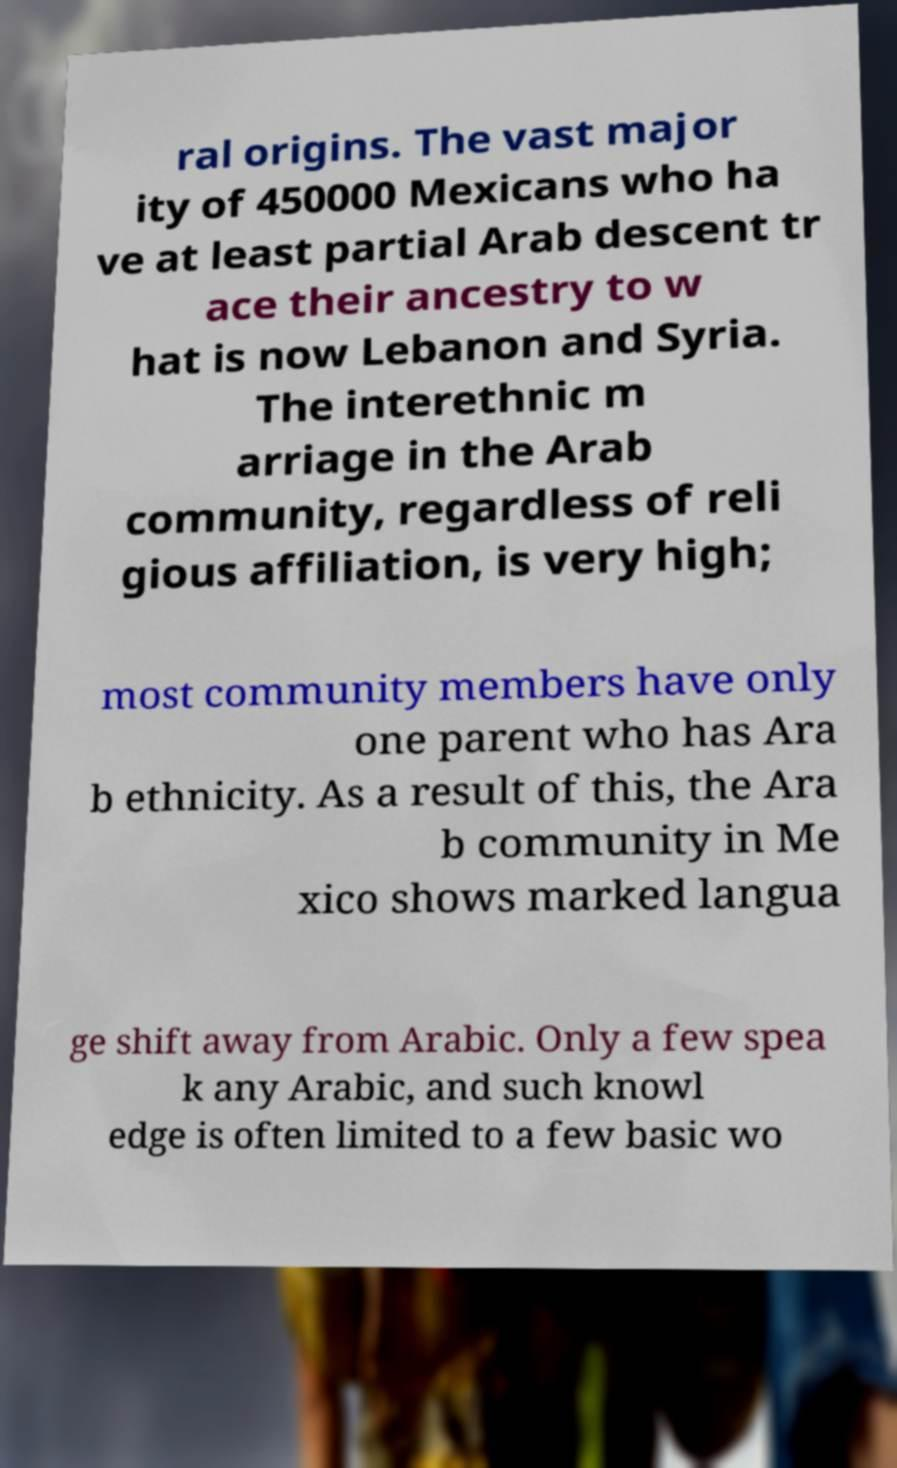Could you assist in decoding the text presented in this image and type it out clearly? ral origins. The vast major ity of 450000 Mexicans who ha ve at least partial Arab descent tr ace their ancestry to w hat is now Lebanon and Syria. The interethnic m arriage in the Arab community, regardless of reli gious affiliation, is very high; most community members have only one parent who has Ara b ethnicity. As a result of this, the Ara b community in Me xico shows marked langua ge shift away from Arabic. Only a few spea k any Arabic, and such knowl edge is often limited to a few basic wo 